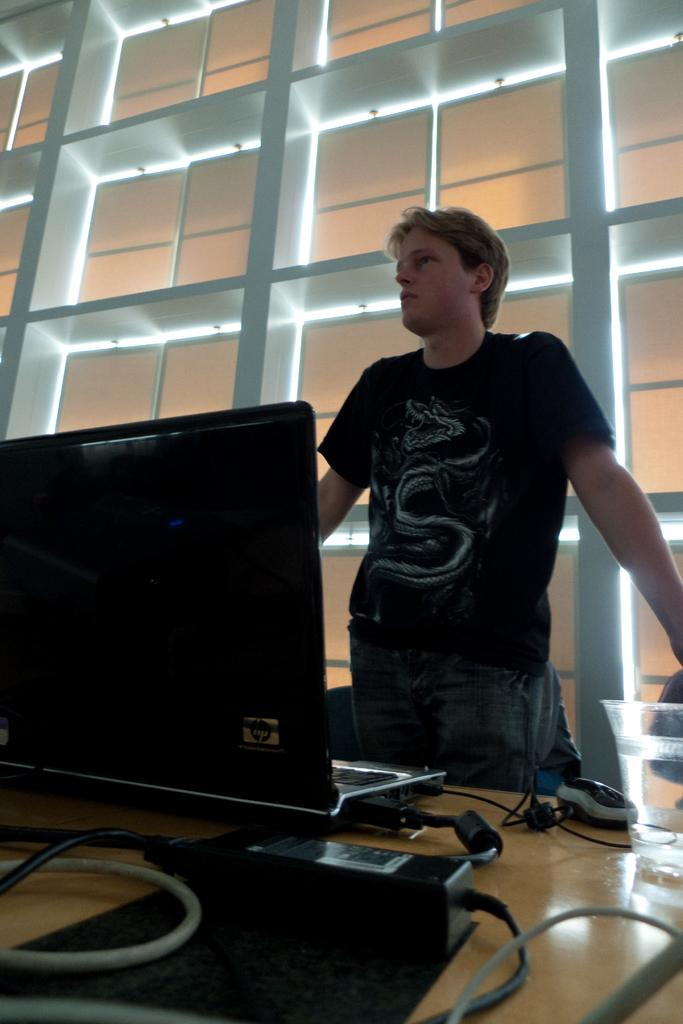What electronic device is on the table in the image? There is a laptop on the table in the image. What is used for input with the laptop? There is a mouse on the table in the image. What is connected to the laptop in the image? There are cables on the table in the image. What is the man in the image doing? The man is standing in the image. What can be seen in the background of the image? There is a wall in the background of the image. What type of toys are scattered on the table in the image? There are no toys present in the image; it features an adapter, cables, a mouse, and a laptop on the table. How many beads can be seen hanging from the wall in the image? There is no mention of beads in the image; it only mentions a wall in the background. 